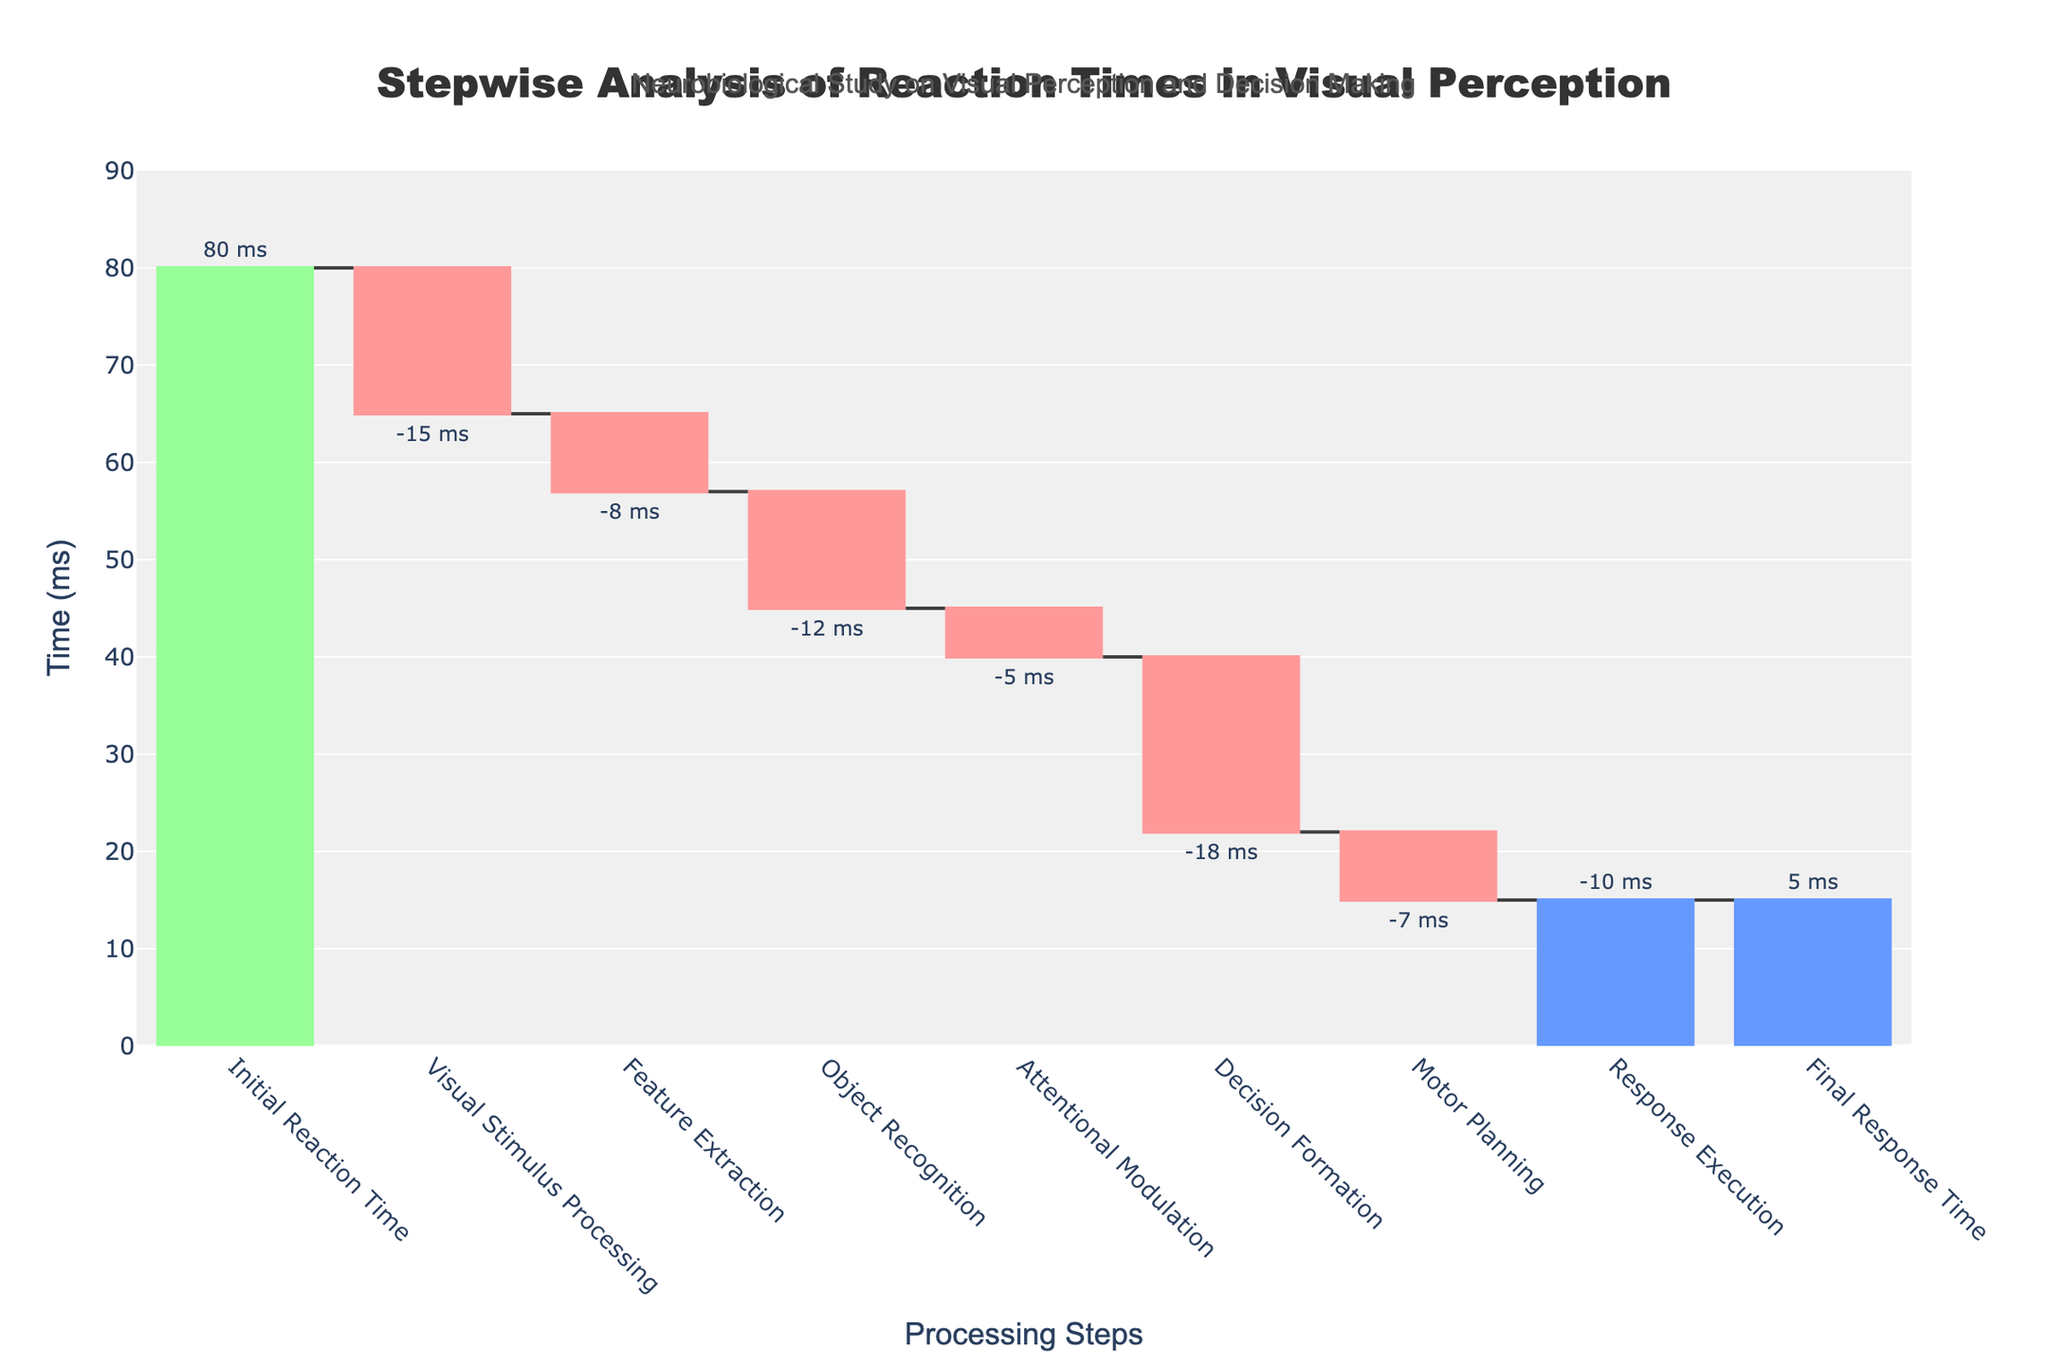What is the title of the chart? The title is written at the top of the chart. It reads, "Stepwise Analysis of Reaction Times in Visual Perception".
Answer: Stepwise Analysis of Reaction Times in Visual Perception How many processing steps are shown on the x-axis? Each label on the x-axis represents a processing step. Counting these labels gives the total number of steps.
Answer: 8 What is the initial reaction time? The initial reaction time is visually indicated by the first bar in the chart, associated with the "Initial Reaction Time" step, which is labeled with 80 ms.
Answer: 80 ms What is the final response time? The final response time is visually indicated by the last bar in the chart, associated with the "Final Response Time" step, which is labeled with 5 ms.
Answer: 5 ms How much time does Visual Stimulus Processing reduce the reaction time by? The chart shows a negative value for the "Visual Stimulus Processing" step, indicating a reduction. This value is labeled as -15 ms.
Answer: 15 ms Which step reduces the reaction time the most? By comparing all the steps with negative values (decreases), the largest absolute value indicates the most reduction. "Decision Formation" has the largest negative change with -18 ms.
Answer: Decision Formation What is the cumulative time after the "Feature Extraction" step? Start with the initial reaction time (80 ms), and add the changes for "Visual Stimulus Processing" (-15 ms: 80 - 15 = 65) and "Feature Extraction" (-8 ms: 65 - 8 = 57).
Answer: 57 ms What is the total reduction in reaction time from Visual Stimulus Processing to Decision Formation? Sum the reductions from "Visual Stimulus Processing" to "Decision Formation":
- Visual Stimulus Processing: -15 ms
- Feature Extraction: -8 ms
- Object Recognition: -12 ms
- Attentional Modulation: -5 ms
- Decision Formation: -18 ms
Sum these values: (-15) + (-8) + (-12) + (-5) + (-18) = -58 ms
Answer: 58 ms How does Attentional Modulation affect the reaction time compared to Motor Planning? Attentional Modulation reduces the reaction time by 5 ms, as indicated by -5 ms, while Motor Planning reduces it by 7 ms, as indicated by -7 ms. Since -7 ms is a larger reduction than -5 ms, Motor Planning has a greater effect.
Answer: Motor Planning reduces reaction time more What is the difference in reaction time before and after the Response Execution step? The time before Response Execution is the cumulative value at "Motor Planning," which is 15 ms. The time after Response Execution is the cumulative value at "Final Response Time," which is 5 ms. Difference: 15 ms - 5 ms = 10 ms.
Answer: 10 ms 